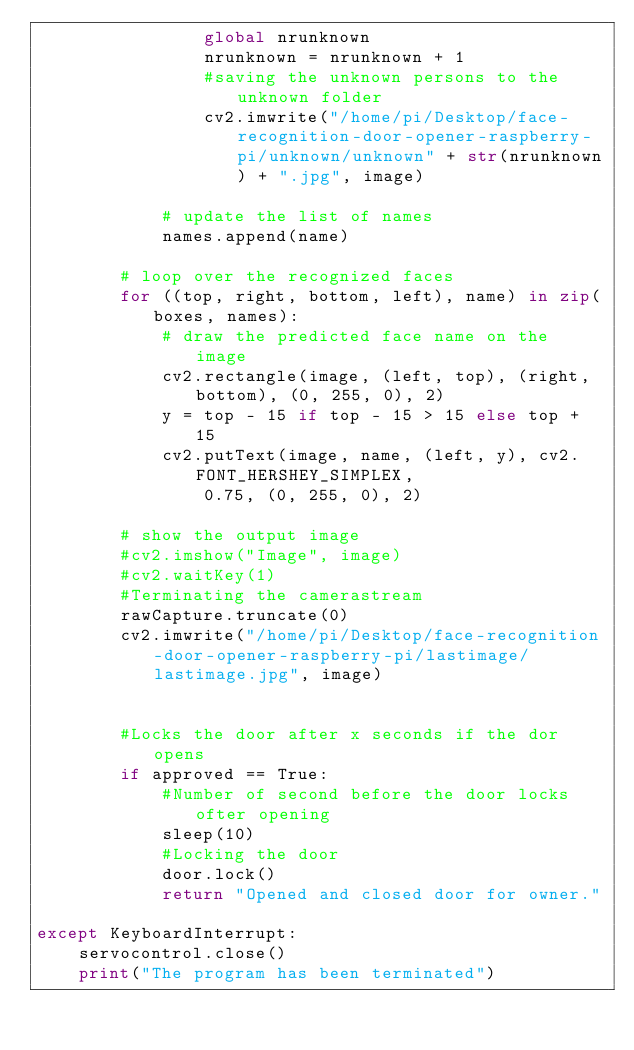Convert code to text. <code><loc_0><loc_0><loc_500><loc_500><_Python_>                global nrunknown
                nrunknown = nrunknown + 1
                #saving the unknown persons to the unknown folder
                cv2.imwrite("/home/pi/Desktop/face-recognition-door-opener-raspberry-pi/unknown/unknown" + str(nrunknown) + ".jpg", image)
            
            # update the list of names
            names.append(name)

        # loop over the recognized faces
        for ((top, right, bottom, left), name) in zip(boxes, names):
            # draw the predicted face name on the image
            cv2.rectangle(image, (left, top), (right, bottom), (0, 255, 0), 2)
            y = top - 15 if top - 15 > 15 else top + 15
            cv2.putText(image, name, (left, y), cv2.FONT_HERSHEY_SIMPLEX,
                0.75, (0, 255, 0), 2)

        # show the output image
        #cv2.imshow("Image", image)
        #cv2.waitKey(1)
        #Terminating the camerastream
        rawCapture.truncate(0)
        cv2.imwrite("/home/pi/Desktop/face-recognition-door-opener-raspberry-pi/lastimage/lastimage.jpg", image)

        
        #Locks the door after x seconds if the dor opens
        if approved == True:
            #Number of second before the door locks ofter opening
            sleep(10)
            #Locking the door
            door.lock()
            return "Opened and closed door for owner."
            
except KeyboardInterrupt:
    servocontrol.close()
    print("The program has been terminated")
    
</code> 